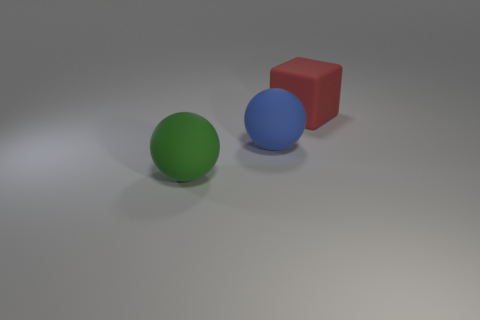Add 1 green rubber cubes. How many objects exist? 4 Subtract all blocks. How many objects are left? 2 Subtract 1 spheres. How many spheres are left? 1 Subtract all purple spheres. Subtract all yellow cylinders. How many spheres are left? 2 Subtract all cyan cylinders. How many brown blocks are left? 0 Subtract all big blue rubber objects. Subtract all small green rubber objects. How many objects are left? 2 Add 1 big blocks. How many big blocks are left? 2 Add 3 small blue rubber cylinders. How many small blue rubber cylinders exist? 3 Subtract 0 brown cylinders. How many objects are left? 3 